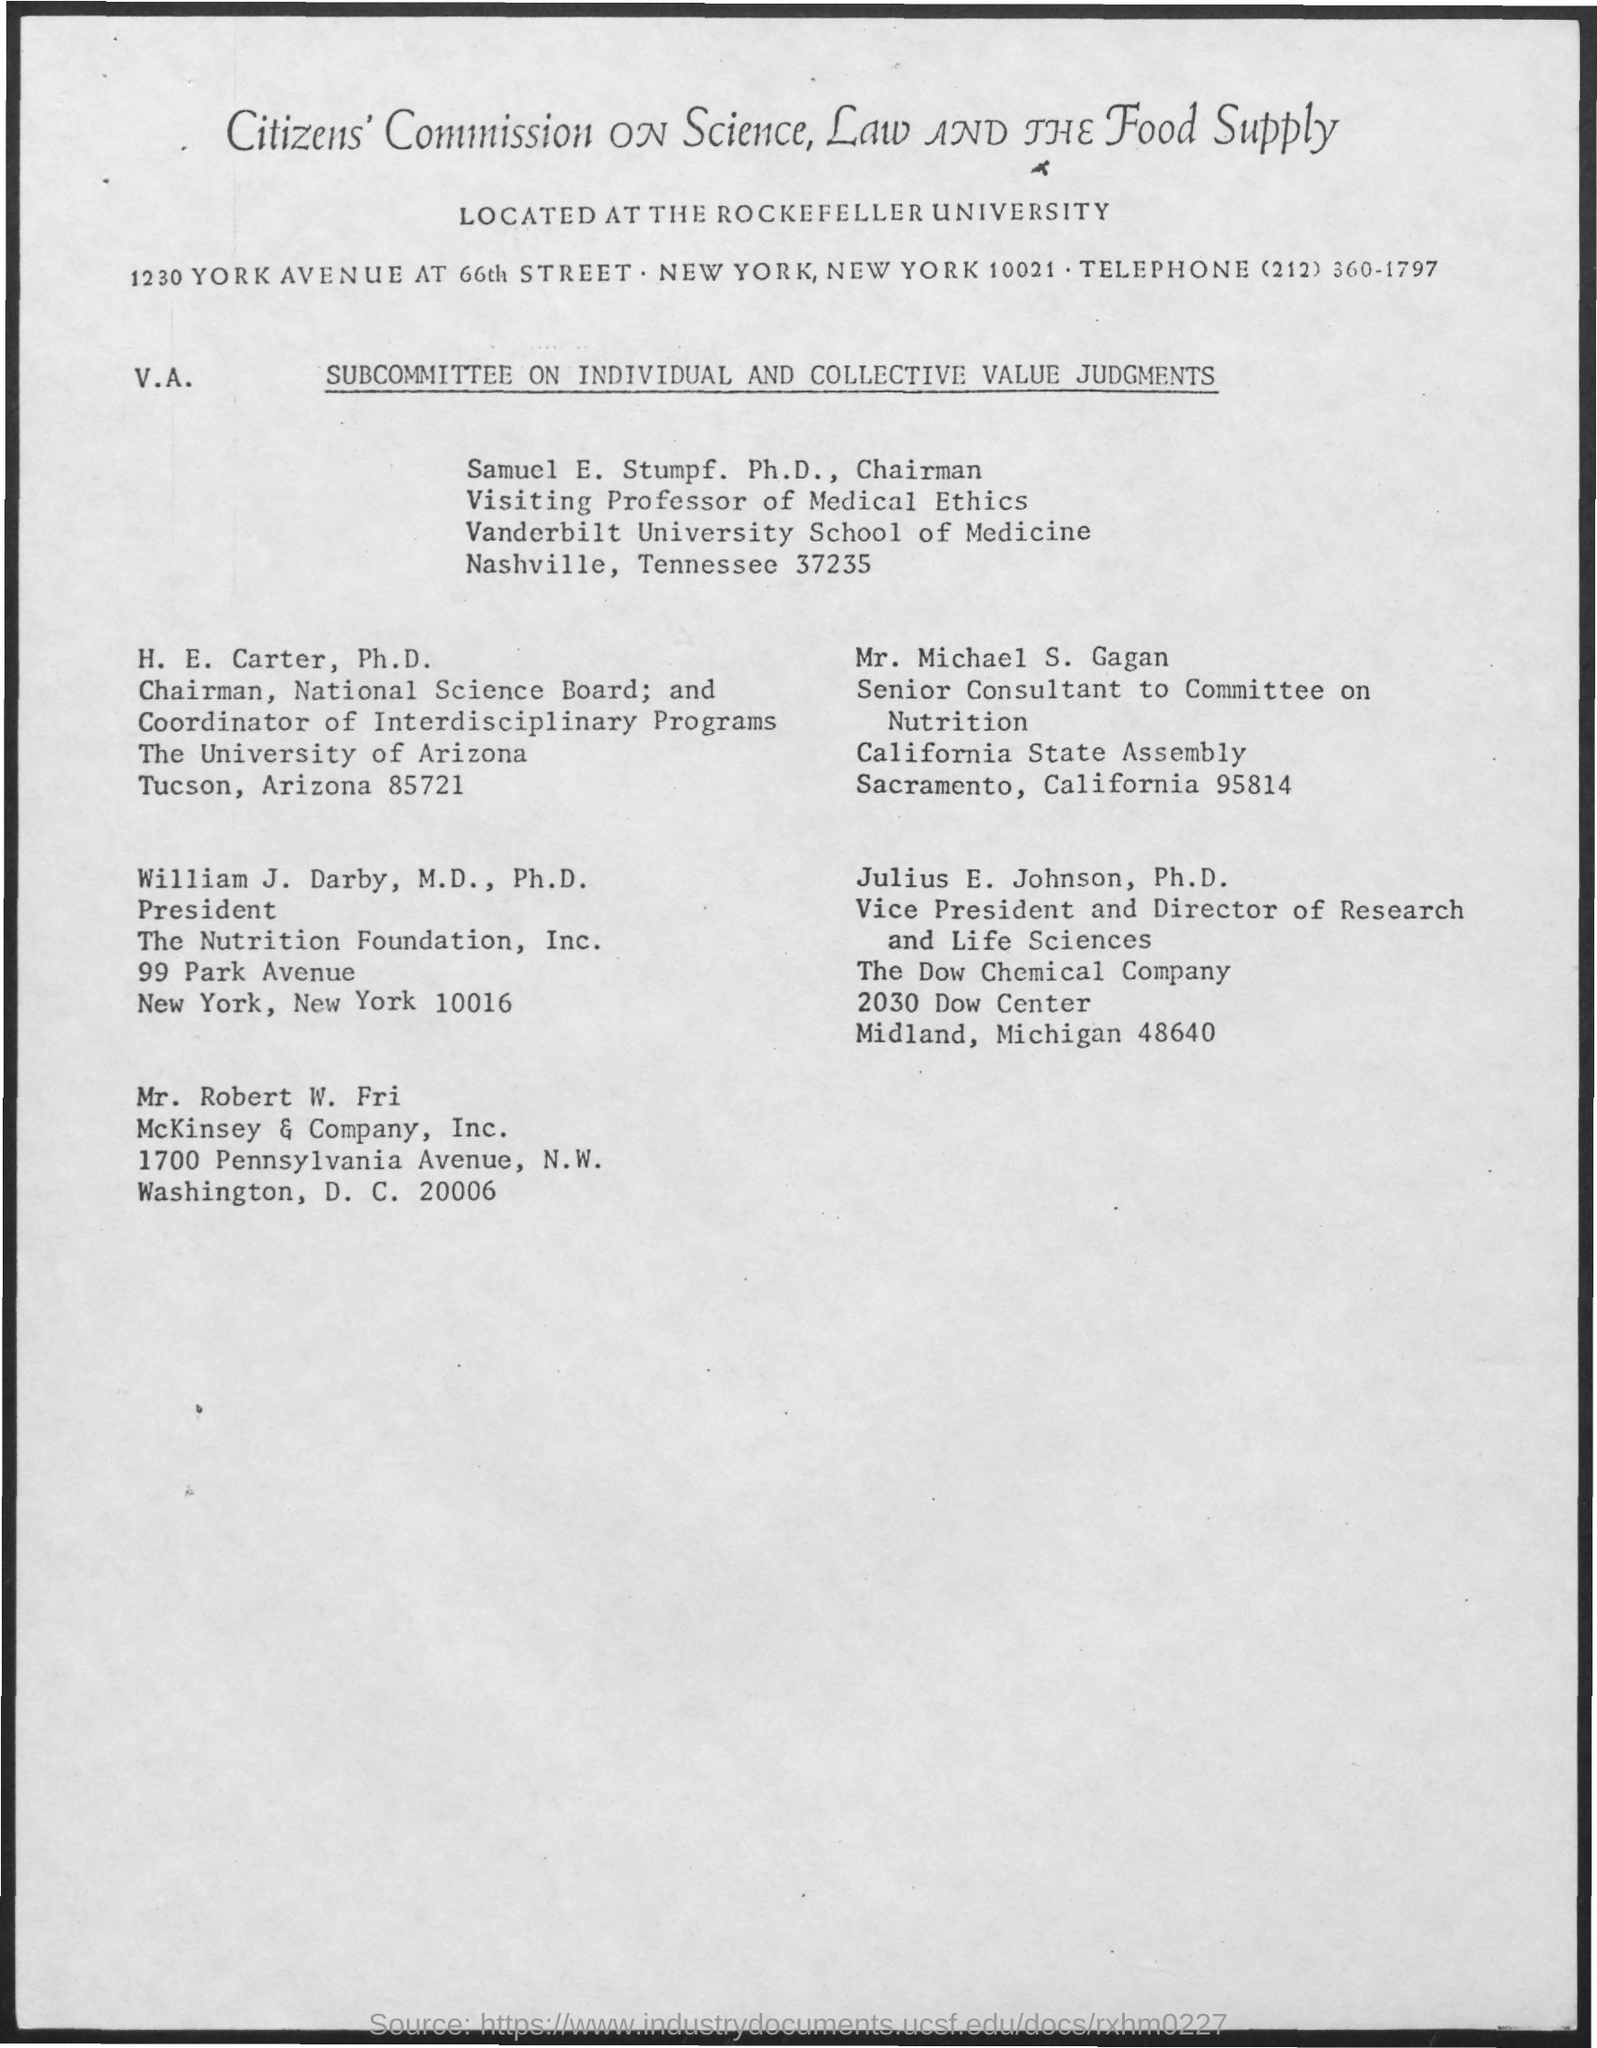Point out several critical features in this image. H.E. Carter belongs to the University of Arizona. William J. Darby is designated as the President. The telephone number mentioned on the given page is (212) 360-1797. Mr. Michael S. Gagan is designated as a senior consultant to the committee on nutrition. 